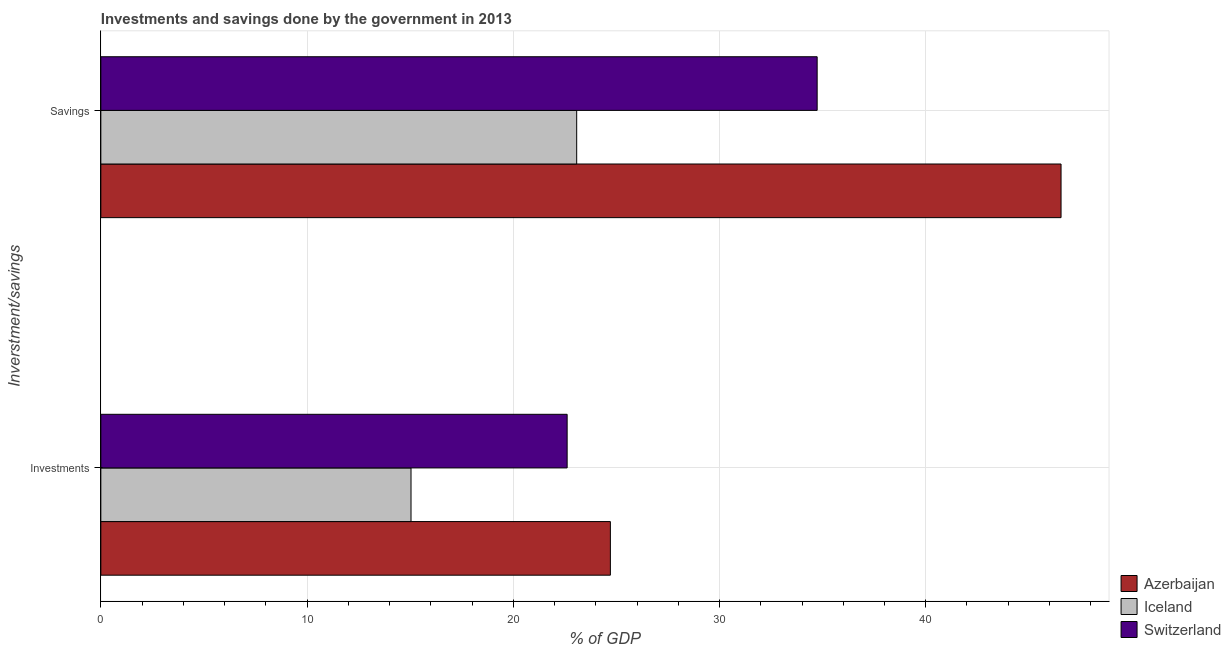How many different coloured bars are there?
Give a very brief answer. 3. How many groups of bars are there?
Ensure brevity in your answer.  2. Are the number of bars per tick equal to the number of legend labels?
Your response must be concise. Yes. How many bars are there on the 2nd tick from the bottom?
Make the answer very short. 3. What is the label of the 1st group of bars from the top?
Ensure brevity in your answer.  Savings. What is the savings of government in Switzerland?
Make the answer very short. 34.74. Across all countries, what is the maximum investments of government?
Your answer should be compact. 24.71. Across all countries, what is the minimum investments of government?
Keep it short and to the point. 15.04. In which country was the investments of government maximum?
Offer a terse response. Azerbaijan. In which country was the investments of government minimum?
Offer a very short reply. Iceland. What is the total investments of government in the graph?
Offer a terse response. 62.36. What is the difference between the investments of government in Azerbaijan and that in Iceland?
Offer a terse response. 9.67. What is the difference between the investments of government in Switzerland and the savings of government in Iceland?
Your answer should be very brief. -0.46. What is the average savings of government per country?
Ensure brevity in your answer.  34.79. What is the difference between the savings of government and investments of government in Azerbaijan?
Keep it short and to the point. 21.85. In how many countries, is the savings of government greater than 18 %?
Offer a very short reply. 3. What is the ratio of the savings of government in Iceland to that in Azerbaijan?
Provide a succinct answer. 0.5. Is the investments of government in Iceland less than that in Switzerland?
Your answer should be compact. Yes. In how many countries, is the savings of government greater than the average savings of government taken over all countries?
Make the answer very short. 1. What does the 1st bar from the bottom in Investments represents?
Provide a short and direct response. Azerbaijan. How many bars are there?
Offer a terse response. 6. How many countries are there in the graph?
Make the answer very short. 3. What is the difference between two consecutive major ticks on the X-axis?
Provide a succinct answer. 10. Does the graph contain any zero values?
Your answer should be compact. No. What is the title of the graph?
Provide a succinct answer. Investments and savings done by the government in 2013. Does "Uzbekistan" appear as one of the legend labels in the graph?
Make the answer very short. No. What is the label or title of the X-axis?
Your answer should be compact. % of GDP. What is the label or title of the Y-axis?
Your answer should be very brief. Inverstment/savings. What is the % of GDP in Azerbaijan in Investments?
Provide a succinct answer. 24.71. What is the % of GDP of Iceland in Investments?
Make the answer very short. 15.04. What is the % of GDP in Switzerland in Investments?
Your response must be concise. 22.61. What is the % of GDP in Azerbaijan in Savings?
Make the answer very short. 46.56. What is the % of GDP of Iceland in Savings?
Your answer should be very brief. 23.07. What is the % of GDP of Switzerland in Savings?
Your answer should be compact. 34.74. Across all Inverstment/savings, what is the maximum % of GDP of Azerbaijan?
Keep it short and to the point. 46.56. Across all Inverstment/savings, what is the maximum % of GDP in Iceland?
Give a very brief answer. 23.07. Across all Inverstment/savings, what is the maximum % of GDP of Switzerland?
Provide a short and direct response. 34.74. Across all Inverstment/savings, what is the minimum % of GDP in Azerbaijan?
Give a very brief answer. 24.71. Across all Inverstment/savings, what is the minimum % of GDP in Iceland?
Keep it short and to the point. 15.04. Across all Inverstment/savings, what is the minimum % of GDP of Switzerland?
Your answer should be very brief. 22.61. What is the total % of GDP in Azerbaijan in the graph?
Your answer should be very brief. 71.27. What is the total % of GDP in Iceland in the graph?
Offer a very short reply. 38.12. What is the total % of GDP of Switzerland in the graph?
Offer a very short reply. 57.35. What is the difference between the % of GDP in Azerbaijan in Investments and that in Savings?
Offer a terse response. -21.85. What is the difference between the % of GDP of Iceland in Investments and that in Savings?
Your answer should be very brief. -8.03. What is the difference between the % of GDP in Switzerland in Investments and that in Savings?
Provide a short and direct response. -12.12. What is the difference between the % of GDP of Azerbaijan in Investments and the % of GDP of Iceland in Savings?
Your answer should be compact. 1.63. What is the difference between the % of GDP of Azerbaijan in Investments and the % of GDP of Switzerland in Savings?
Make the answer very short. -10.03. What is the difference between the % of GDP in Iceland in Investments and the % of GDP in Switzerland in Savings?
Give a very brief answer. -19.69. What is the average % of GDP in Azerbaijan per Inverstment/savings?
Provide a short and direct response. 35.63. What is the average % of GDP of Iceland per Inverstment/savings?
Ensure brevity in your answer.  19.06. What is the average % of GDP of Switzerland per Inverstment/savings?
Keep it short and to the point. 28.67. What is the difference between the % of GDP of Azerbaijan and % of GDP of Iceland in Investments?
Provide a short and direct response. 9.67. What is the difference between the % of GDP of Azerbaijan and % of GDP of Switzerland in Investments?
Your answer should be very brief. 2.1. What is the difference between the % of GDP in Iceland and % of GDP in Switzerland in Investments?
Offer a terse response. -7.57. What is the difference between the % of GDP in Azerbaijan and % of GDP in Iceland in Savings?
Keep it short and to the point. 23.49. What is the difference between the % of GDP of Azerbaijan and % of GDP of Switzerland in Savings?
Keep it short and to the point. 11.83. What is the difference between the % of GDP of Iceland and % of GDP of Switzerland in Savings?
Offer a terse response. -11.66. What is the ratio of the % of GDP of Azerbaijan in Investments to that in Savings?
Provide a short and direct response. 0.53. What is the ratio of the % of GDP in Iceland in Investments to that in Savings?
Your answer should be very brief. 0.65. What is the ratio of the % of GDP of Switzerland in Investments to that in Savings?
Offer a terse response. 0.65. What is the difference between the highest and the second highest % of GDP of Azerbaijan?
Your answer should be compact. 21.85. What is the difference between the highest and the second highest % of GDP in Iceland?
Your answer should be compact. 8.03. What is the difference between the highest and the second highest % of GDP of Switzerland?
Provide a succinct answer. 12.12. What is the difference between the highest and the lowest % of GDP in Azerbaijan?
Give a very brief answer. 21.85. What is the difference between the highest and the lowest % of GDP of Iceland?
Your response must be concise. 8.03. What is the difference between the highest and the lowest % of GDP in Switzerland?
Your response must be concise. 12.12. 